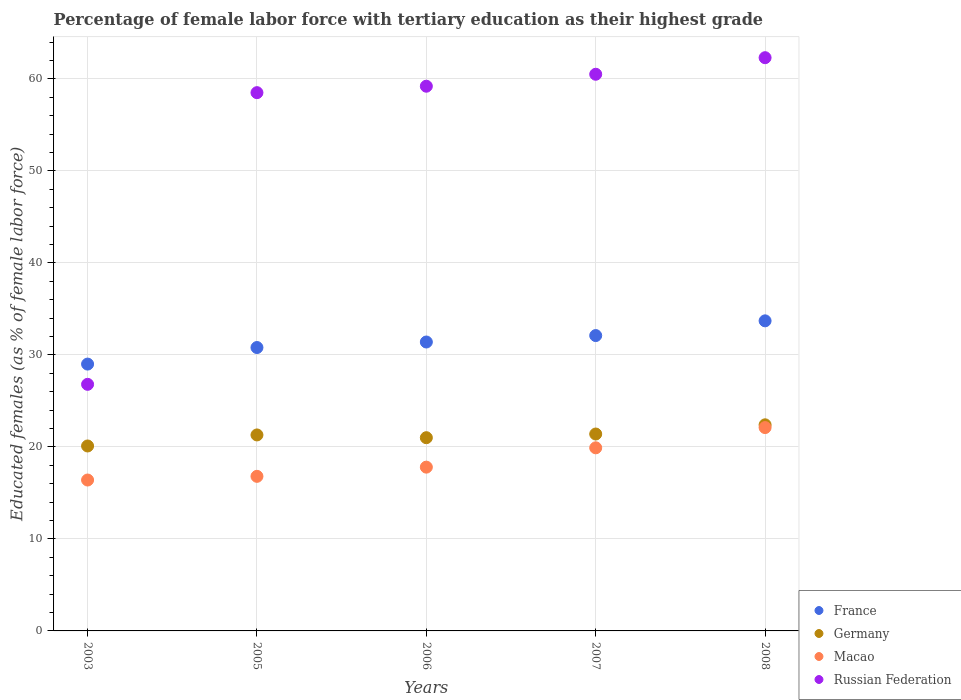How many different coloured dotlines are there?
Offer a very short reply. 4. What is the percentage of female labor force with tertiary education in France in 2007?
Your answer should be compact. 32.1. Across all years, what is the maximum percentage of female labor force with tertiary education in Russian Federation?
Keep it short and to the point. 62.3. Across all years, what is the minimum percentage of female labor force with tertiary education in Germany?
Ensure brevity in your answer.  20.1. What is the total percentage of female labor force with tertiary education in Macao in the graph?
Keep it short and to the point. 93. What is the difference between the percentage of female labor force with tertiary education in Macao in 2003 and that in 2005?
Your response must be concise. -0.4. What is the difference between the percentage of female labor force with tertiary education in France in 2006 and the percentage of female labor force with tertiary education in Russian Federation in 2005?
Give a very brief answer. -27.1. What is the average percentage of female labor force with tertiary education in Russian Federation per year?
Give a very brief answer. 53.46. In the year 2008, what is the difference between the percentage of female labor force with tertiary education in Macao and percentage of female labor force with tertiary education in Germany?
Offer a very short reply. -0.3. What is the ratio of the percentage of female labor force with tertiary education in Germany in 2005 to that in 2008?
Make the answer very short. 0.95. Is the percentage of female labor force with tertiary education in France in 2007 less than that in 2008?
Provide a short and direct response. Yes. Is the difference between the percentage of female labor force with tertiary education in Macao in 2003 and 2005 greater than the difference between the percentage of female labor force with tertiary education in Germany in 2003 and 2005?
Offer a very short reply. Yes. What is the difference between the highest and the second highest percentage of female labor force with tertiary education in Macao?
Give a very brief answer. 2.2. What is the difference between the highest and the lowest percentage of female labor force with tertiary education in France?
Offer a very short reply. 4.7. Is it the case that in every year, the sum of the percentage of female labor force with tertiary education in Macao and percentage of female labor force with tertiary education in France  is greater than the percentage of female labor force with tertiary education in Germany?
Offer a very short reply. Yes. Is the percentage of female labor force with tertiary education in Germany strictly less than the percentage of female labor force with tertiary education in France over the years?
Ensure brevity in your answer.  Yes. Where does the legend appear in the graph?
Keep it short and to the point. Bottom right. What is the title of the graph?
Provide a succinct answer. Percentage of female labor force with tertiary education as their highest grade. Does "Iceland" appear as one of the legend labels in the graph?
Provide a short and direct response. No. What is the label or title of the X-axis?
Give a very brief answer. Years. What is the label or title of the Y-axis?
Provide a succinct answer. Educated females (as % of female labor force). What is the Educated females (as % of female labor force) in France in 2003?
Your answer should be compact. 29. What is the Educated females (as % of female labor force) of Germany in 2003?
Offer a very short reply. 20.1. What is the Educated females (as % of female labor force) of Macao in 2003?
Provide a succinct answer. 16.4. What is the Educated females (as % of female labor force) of Russian Federation in 2003?
Ensure brevity in your answer.  26.8. What is the Educated females (as % of female labor force) of France in 2005?
Provide a short and direct response. 30.8. What is the Educated females (as % of female labor force) in Germany in 2005?
Ensure brevity in your answer.  21.3. What is the Educated females (as % of female labor force) of Macao in 2005?
Offer a very short reply. 16.8. What is the Educated females (as % of female labor force) in Russian Federation in 2005?
Give a very brief answer. 58.5. What is the Educated females (as % of female labor force) of France in 2006?
Give a very brief answer. 31.4. What is the Educated females (as % of female labor force) in Germany in 2006?
Give a very brief answer. 21. What is the Educated females (as % of female labor force) in Macao in 2006?
Ensure brevity in your answer.  17.8. What is the Educated females (as % of female labor force) of Russian Federation in 2006?
Your answer should be compact. 59.2. What is the Educated females (as % of female labor force) of France in 2007?
Make the answer very short. 32.1. What is the Educated females (as % of female labor force) in Germany in 2007?
Provide a short and direct response. 21.4. What is the Educated females (as % of female labor force) in Macao in 2007?
Your answer should be very brief. 19.9. What is the Educated females (as % of female labor force) in Russian Federation in 2007?
Give a very brief answer. 60.5. What is the Educated females (as % of female labor force) of France in 2008?
Give a very brief answer. 33.7. What is the Educated females (as % of female labor force) in Germany in 2008?
Ensure brevity in your answer.  22.4. What is the Educated females (as % of female labor force) in Macao in 2008?
Make the answer very short. 22.1. What is the Educated females (as % of female labor force) in Russian Federation in 2008?
Offer a terse response. 62.3. Across all years, what is the maximum Educated females (as % of female labor force) of France?
Your response must be concise. 33.7. Across all years, what is the maximum Educated females (as % of female labor force) of Germany?
Provide a short and direct response. 22.4. Across all years, what is the maximum Educated females (as % of female labor force) of Macao?
Provide a short and direct response. 22.1. Across all years, what is the maximum Educated females (as % of female labor force) of Russian Federation?
Provide a short and direct response. 62.3. Across all years, what is the minimum Educated females (as % of female labor force) of France?
Your answer should be very brief. 29. Across all years, what is the minimum Educated females (as % of female labor force) in Germany?
Your answer should be very brief. 20.1. Across all years, what is the minimum Educated females (as % of female labor force) in Macao?
Ensure brevity in your answer.  16.4. Across all years, what is the minimum Educated females (as % of female labor force) in Russian Federation?
Keep it short and to the point. 26.8. What is the total Educated females (as % of female labor force) of France in the graph?
Your answer should be very brief. 157. What is the total Educated females (as % of female labor force) in Germany in the graph?
Offer a terse response. 106.2. What is the total Educated females (as % of female labor force) of Macao in the graph?
Your answer should be compact. 93. What is the total Educated females (as % of female labor force) of Russian Federation in the graph?
Keep it short and to the point. 267.3. What is the difference between the Educated females (as % of female labor force) in Germany in 2003 and that in 2005?
Your answer should be very brief. -1.2. What is the difference between the Educated females (as % of female labor force) of Russian Federation in 2003 and that in 2005?
Give a very brief answer. -31.7. What is the difference between the Educated females (as % of female labor force) in France in 2003 and that in 2006?
Your answer should be very brief. -2.4. What is the difference between the Educated females (as % of female labor force) of Macao in 2003 and that in 2006?
Provide a short and direct response. -1.4. What is the difference between the Educated females (as % of female labor force) in Russian Federation in 2003 and that in 2006?
Your response must be concise. -32.4. What is the difference between the Educated females (as % of female labor force) of France in 2003 and that in 2007?
Ensure brevity in your answer.  -3.1. What is the difference between the Educated females (as % of female labor force) of Germany in 2003 and that in 2007?
Ensure brevity in your answer.  -1.3. What is the difference between the Educated females (as % of female labor force) in Russian Federation in 2003 and that in 2007?
Offer a terse response. -33.7. What is the difference between the Educated females (as % of female labor force) of Germany in 2003 and that in 2008?
Offer a very short reply. -2.3. What is the difference between the Educated females (as % of female labor force) of Macao in 2003 and that in 2008?
Provide a succinct answer. -5.7. What is the difference between the Educated females (as % of female labor force) in Russian Federation in 2003 and that in 2008?
Your response must be concise. -35.5. What is the difference between the Educated females (as % of female labor force) in Germany in 2005 and that in 2006?
Provide a succinct answer. 0.3. What is the difference between the Educated females (as % of female labor force) of Macao in 2005 and that in 2006?
Make the answer very short. -1. What is the difference between the Educated females (as % of female labor force) of France in 2005 and that in 2007?
Give a very brief answer. -1.3. What is the difference between the Educated females (as % of female labor force) of Macao in 2005 and that in 2007?
Offer a very short reply. -3.1. What is the difference between the Educated females (as % of female labor force) in Germany in 2005 and that in 2008?
Your response must be concise. -1.1. What is the difference between the Educated females (as % of female labor force) in Russian Federation in 2005 and that in 2008?
Provide a short and direct response. -3.8. What is the difference between the Educated females (as % of female labor force) of Germany in 2006 and that in 2007?
Offer a terse response. -0.4. What is the difference between the Educated females (as % of female labor force) in France in 2006 and that in 2008?
Ensure brevity in your answer.  -2.3. What is the difference between the Educated females (as % of female labor force) of Germany in 2006 and that in 2008?
Provide a succinct answer. -1.4. What is the difference between the Educated females (as % of female labor force) in Macao in 2006 and that in 2008?
Offer a terse response. -4.3. What is the difference between the Educated females (as % of female labor force) of Russian Federation in 2006 and that in 2008?
Your answer should be compact. -3.1. What is the difference between the Educated females (as % of female labor force) of France in 2003 and the Educated females (as % of female labor force) of Germany in 2005?
Your answer should be compact. 7.7. What is the difference between the Educated females (as % of female labor force) of France in 2003 and the Educated females (as % of female labor force) of Macao in 2005?
Offer a terse response. 12.2. What is the difference between the Educated females (as % of female labor force) in France in 2003 and the Educated females (as % of female labor force) in Russian Federation in 2005?
Offer a very short reply. -29.5. What is the difference between the Educated females (as % of female labor force) in Germany in 2003 and the Educated females (as % of female labor force) in Macao in 2005?
Give a very brief answer. 3.3. What is the difference between the Educated females (as % of female labor force) in Germany in 2003 and the Educated females (as % of female labor force) in Russian Federation in 2005?
Make the answer very short. -38.4. What is the difference between the Educated females (as % of female labor force) of Macao in 2003 and the Educated females (as % of female labor force) of Russian Federation in 2005?
Make the answer very short. -42.1. What is the difference between the Educated females (as % of female labor force) in France in 2003 and the Educated females (as % of female labor force) in Germany in 2006?
Ensure brevity in your answer.  8. What is the difference between the Educated females (as % of female labor force) of France in 2003 and the Educated females (as % of female labor force) of Russian Federation in 2006?
Your answer should be very brief. -30.2. What is the difference between the Educated females (as % of female labor force) of Germany in 2003 and the Educated females (as % of female labor force) of Macao in 2006?
Keep it short and to the point. 2.3. What is the difference between the Educated females (as % of female labor force) of Germany in 2003 and the Educated females (as % of female labor force) of Russian Federation in 2006?
Make the answer very short. -39.1. What is the difference between the Educated females (as % of female labor force) in Macao in 2003 and the Educated females (as % of female labor force) in Russian Federation in 2006?
Offer a very short reply. -42.8. What is the difference between the Educated females (as % of female labor force) of France in 2003 and the Educated females (as % of female labor force) of Germany in 2007?
Your response must be concise. 7.6. What is the difference between the Educated females (as % of female labor force) in France in 2003 and the Educated females (as % of female labor force) in Macao in 2007?
Make the answer very short. 9.1. What is the difference between the Educated females (as % of female labor force) of France in 2003 and the Educated females (as % of female labor force) of Russian Federation in 2007?
Your answer should be very brief. -31.5. What is the difference between the Educated females (as % of female labor force) of Germany in 2003 and the Educated females (as % of female labor force) of Macao in 2007?
Offer a very short reply. 0.2. What is the difference between the Educated females (as % of female labor force) of Germany in 2003 and the Educated females (as % of female labor force) of Russian Federation in 2007?
Offer a very short reply. -40.4. What is the difference between the Educated females (as % of female labor force) of Macao in 2003 and the Educated females (as % of female labor force) of Russian Federation in 2007?
Provide a succinct answer. -44.1. What is the difference between the Educated females (as % of female labor force) in France in 2003 and the Educated females (as % of female labor force) in Germany in 2008?
Give a very brief answer. 6.6. What is the difference between the Educated females (as % of female labor force) in France in 2003 and the Educated females (as % of female labor force) in Macao in 2008?
Keep it short and to the point. 6.9. What is the difference between the Educated females (as % of female labor force) of France in 2003 and the Educated females (as % of female labor force) of Russian Federation in 2008?
Offer a terse response. -33.3. What is the difference between the Educated females (as % of female labor force) in Germany in 2003 and the Educated females (as % of female labor force) in Russian Federation in 2008?
Your response must be concise. -42.2. What is the difference between the Educated females (as % of female labor force) of Macao in 2003 and the Educated females (as % of female labor force) of Russian Federation in 2008?
Keep it short and to the point. -45.9. What is the difference between the Educated females (as % of female labor force) in France in 2005 and the Educated females (as % of female labor force) in Germany in 2006?
Make the answer very short. 9.8. What is the difference between the Educated females (as % of female labor force) of France in 2005 and the Educated females (as % of female labor force) of Russian Federation in 2006?
Give a very brief answer. -28.4. What is the difference between the Educated females (as % of female labor force) of Germany in 2005 and the Educated females (as % of female labor force) of Russian Federation in 2006?
Give a very brief answer. -37.9. What is the difference between the Educated females (as % of female labor force) in Macao in 2005 and the Educated females (as % of female labor force) in Russian Federation in 2006?
Ensure brevity in your answer.  -42.4. What is the difference between the Educated females (as % of female labor force) in France in 2005 and the Educated females (as % of female labor force) in Germany in 2007?
Keep it short and to the point. 9.4. What is the difference between the Educated females (as % of female labor force) of France in 2005 and the Educated females (as % of female labor force) of Russian Federation in 2007?
Provide a short and direct response. -29.7. What is the difference between the Educated females (as % of female labor force) in Germany in 2005 and the Educated females (as % of female labor force) in Russian Federation in 2007?
Ensure brevity in your answer.  -39.2. What is the difference between the Educated females (as % of female labor force) in Macao in 2005 and the Educated females (as % of female labor force) in Russian Federation in 2007?
Provide a short and direct response. -43.7. What is the difference between the Educated females (as % of female labor force) in France in 2005 and the Educated females (as % of female labor force) in Macao in 2008?
Provide a short and direct response. 8.7. What is the difference between the Educated females (as % of female labor force) in France in 2005 and the Educated females (as % of female labor force) in Russian Federation in 2008?
Your response must be concise. -31.5. What is the difference between the Educated females (as % of female labor force) of Germany in 2005 and the Educated females (as % of female labor force) of Macao in 2008?
Provide a succinct answer. -0.8. What is the difference between the Educated females (as % of female labor force) of Germany in 2005 and the Educated females (as % of female labor force) of Russian Federation in 2008?
Offer a very short reply. -41. What is the difference between the Educated females (as % of female labor force) in Macao in 2005 and the Educated females (as % of female labor force) in Russian Federation in 2008?
Offer a very short reply. -45.5. What is the difference between the Educated females (as % of female labor force) of France in 2006 and the Educated females (as % of female labor force) of Russian Federation in 2007?
Your answer should be compact. -29.1. What is the difference between the Educated females (as % of female labor force) in Germany in 2006 and the Educated females (as % of female labor force) in Macao in 2007?
Provide a succinct answer. 1.1. What is the difference between the Educated females (as % of female labor force) of Germany in 2006 and the Educated females (as % of female labor force) of Russian Federation in 2007?
Offer a very short reply. -39.5. What is the difference between the Educated females (as % of female labor force) in Macao in 2006 and the Educated females (as % of female labor force) in Russian Federation in 2007?
Ensure brevity in your answer.  -42.7. What is the difference between the Educated females (as % of female labor force) of France in 2006 and the Educated females (as % of female labor force) of Germany in 2008?
Your answer should be very brief. 9. What is the difference between the Educated females (as % of female labor force) of France in 2006 and the Educated females (as % of female labor force) of Russian Federation in 2008?
Provide a short and direct response. -30.9. What is the difference between the Educated females (as % of female labor force) in Germany in 2006 and the Educated females (as % of female labor force) in Russian Federation in 2008?
Keep it short and to the point. -41.3. What is the difference between the Educated females (as % of female labor force) of Macao in 2006 and the Educated females (as % of female labor force) of Russian Federation in 2008?
Provide a succinct answer. -44.5. What is the difference between the Educated females (as % of female labor force) of France in 2007 and the Educated females (as % of female labor force) of Germany in 2008?
Make the answer very short. 9.7. What is the difference between the Educated females (as % of female labor force) of France in 2007 and the Educated females (as % of female labor force) of Macao in 2008?
Your answer should be compact. 10. What is the difference between the Educated females (as % of female labor force) in France in 2007 and the Educated females (as % of female labor force) in Russian Federation in 2008?
Provide a short and direct response. -30.2. What is the difference between the Educated females (as % of female labor force) of Germany in 2007 and the Educated females (as % of female labor force) of Macao in 2008?
Make the answer very short. -0.7. What is the difference between the Educated females (as % of female labor force) of Germany in 2007 and the Educated females (as % of female labor force) of Russian Federation in 2008?
Give a very brief answer. -40.9. What is the difference between the Educated females (as % of female labor force) in Macao in 2007 and the Educated females (as % of female labor force) in Russian Federation in 2008?
Your response must be concise. -42.4. What is the average Educated females (as % of female labor force) of France per year?
Keep it short and to the point. 31.4. What is the average Educated females (as % of female labor force) of Germany per year?
Make the answer very short. 21.24. What is the average Educated females (as % of female labor force) in Russian Federation per year?
Your answer should be compact. 53.46. In the year 2003, what is the difference between the Educated females (as % of female labor force) in France and Educated females (as % of female labor force) in Germany?
Offer a very short reply. 8.9. In the year 2003, what is the difference between the Educated females (as % of female labor force) in France and Educated females (as % of female labor force) in Macao?
Offer a terse response. 12.6. In the year 2003, what is the difference between the Educated females (as % of female labor force) in Germany and Educated females (as % of female labor force) in Macao?
Keep it short and to the point. 3.7. In the year 2003, what is the difference between the Educated females (as % of female labor force) in Macao and Educated females (as % of female labor force) in Russian Federation?
Keep it short and to the point. -10.4. In the year 2005, what is the difference between the Educated females (as % of female labor force) in France and Educated females (as % of female labor force) in Germany?
Ensure brevity in your answer.  9.5. In the year 2005, what is the difference between the Educated females (as % of female labor force) in France and Educated females (as % of female labor force) in Macao?
Offer a very short reply. 14. In the year 2005, what is the difference between the Educated females (as % of female labor force) of France and Educated females (as % of female labor force) of Russian Federation?
Your answer should be compact. -27.7. In the year 2005, what is the difference between the Educated females (as % of female labor force) of Germany and Educated females (as % of female labor force) of Russian Federation?
Your answer should be very brief. -37.2. In the year 2005, what is the difference between the Educated females (as % of female labor force) in Macao and Educated females (as % of female labor force) in Russian Federation?
Give a very brief answer. -41.7. In the year 2006, what is the difference between the Educated females (as % of female labor force) of France and Educated females (as % of female labor force) of Germany?
Offer a very short reply. 10.4. In the year 2006, what is the difference between the Educated females (as % of female labor force) of France and Educated females (as % of female labor force) of Russian Federation?
Ensure brevity in your answer.  -27.8. In the year 2006, what is the difference between the Educated females (as % of female labor force) in Germany and Educated females (as % of female labor force) in Macao?
Offer a terse response. 3.2. In the year 2006, what is the difference between the Educated females (as % of female labor force) of Germany and Educated females (as % of female labor force) of Russian Federation?
Offer a very short reply. -38.2. In the year 2006, what is the difference between the Educated females (as % of female labor force) in Macao and Educated females (as % of female labor force) in Russian Federation?
Provide a short and direct response. -41.4. In the year 2007, what is the difference between the Educated females (as % of female labor force) of France and Educated females (as % of female labor force) of Germany?
Offer a terse response. 10.7. In the year 2007, what is the difference between the Educated females (as % of female labor force) of France and Educated females (as % of female labor force) of Macao?
Offer a very short reply. 12.2. In the year 2007, what is the difference between the Educated females (as % of female labor force) of France and Educated females (as % of female labor force) of Russian Federation?
Offer a terse response. -28.4. In the year 2007, what is the difference between the Educated females (as % of female labor force) in Germany and Educated females (as % of female labor force) in Macao?
Provide a short and direct response. 1.5. In the year 2007, what is the difference between the Educated females (as % of female labor force) of Germany and Educated females (as % of female labor force) of Russian Federation?
Your answer should be compact. -39.1. In the year 2007, what is the difference between the Educated females (as % of female labor force) in Macao and Educated females (as % of female labor force) in Russian Federation?
Provide a succinct answer. -40.6. In the year 2008, what is the difference between the Educated females (as % of female labor force) in France and Educated females (as % of female labor force) in Germany?
Offer a very short reply. 11.3. In the year 2008, what is the difference between the Educated females (as % of female labor force) of France and Educated females (as % of female labor force) of Macao?
Offer a terse response. 11.6. In the year 2008, what is the difference between the Educated females (as % of female labor force) of France and Educated females (as % of female labor force) of Russian Federation?
Provide a short and direct response. -28.6. In the year 2008, what is the difference between the Educated females (as % of female labor force) in Germany and Educated females (as % of female labor force) in Macao?
Ensure brevity in your answer.  0.3. In the year 2008, what is the difference between the Educated females (as % of female labor force) in Germany and Educated females (as % of female labor force) in Russian Federation?
Offer a terse response. -39.9. In the year 2008, what is the difference between the Educated females (as % of female labor force) in Macao and Educated females (as % of female labor force) in Russian Federation?
Make the answer very short. -40.2. What is the ratio of the Educated females (as % of female labor force) in France in 2003 to that in 2005?
Offer a terse response. 0.94. What is the ratio of the Educated females (as % of female labor force) of Germany in 2003 to that in 2005?
Your response must be concise. 0.94. What is the ratio of the Educated females (as % of female labor force) of Macao in 2003 to that in 2005?
Offer a terse response. 0.98. What is the ratio of the Educated females (as % of female labor force) of Russian Federation in 2003 to that in 2005?
Your answer should be compact. 0.46. What is the ratio of the Educated females (as % of female labor force) in France in 2003 to that in 2006?
Your response must be concise. 0.92. What is the ratio of the Educated females (as % of female labor force) of Germany in 2003 to that in 2006?
Offer a very short reply. 0.96. What is the ratio of the Educated females (as % of female labor force) of Macao in 2003 to that in 2006?
Your response must be concise. 0.92. What is the ratio of the Educated females (as % of female labor force) of Russian Federation in 2003 to that in 2006?
Provide a short and direct response. 0.45. What is the ratio of the Educated females (as % of female labor force) in France in 2003 to that in 2007?
Your answer should be very brief. 0.9. What is the ratio of the Educated females (as % of female labor force) in Germany in 2003 to that in 2007?
Offer a very short reply. 0.94. What is the ratio of the Educated females (as % of female labor force) of Macao in 2003 to that in 2007?
Offer a terse response. 0.82. What is the ratio of the Educated females (as % of female labor force) of Russian Federation in 2003 to that in 2007?
Make the answer very short. 0.44. What is the ratio of the Educated females (as % of female labor force) in France in 2003 to that in 2008?
Ensure brevity in your answer.  0.86. What is the ratio of the Educated females (as % of female labor force) in Germany in 2003 to that in 2008?
Your answer should be very brief. 0.9. What is the ratio of the Educated females (as % of female labor force) of Macao in 2003 to that in 2008?
Your response must be concise. 0.74. What is the ratio of the Educated females (as % of female labor force) in Russian Federation in 2003 to that in 2008?
Keep it short and to the point. 0.43. What is the ratio of the Educated females (as % of female labor force) in France in 2005 to that in 2006?
Give a very brief answer. 0.98. What is the ratio of the Educated females (as % of female labor force) of Germany in 2005 to that in 2006?
Offer a very short reply. 1.01. What is the ratio of the Educated females (as % of female labor force) of Macao in 2005 to that in 2006?
Your answer should be very brief. 0.94. What is the ratio of the Educated females (as % of female labor force) in Russian Federation in 2005 to that in 2006?
Give a very brief answer. 0.99. What is the ratio of the Educated females (as % of female labor force) in France in 2005 to that in 2007?
Provide a succinct answer. 0.96. What is the ratio of the Educated females (as % of female labor force) of Germany in 2005 to that in 2007?
Your answer should be very brief. 1. What is the ratio of the Educated females (as % of female labor force) of Macao in 2005 to that in 2007?
Offer a terse response. 0.84. What is the ratio of the Educated females (as % of female labor force) in Russian Federation in 2005 to that in 2007?
Your response must be concise. 0.97. What is the ratio of the Educated females (as % of female labor force) in France in 2005 to that in 2008?
Offer a very short reply. 0.91. What is the ratio of the Educated females (as % of female labor force) in Germany in 2005 to that in 2008?
Your response must be concise. 0.95. What is the ratio of the Educated females (as % of female labor force) in Macao in 2005 to that in 2008?
Your answer should be compact. 0.76. What is the ratio of the Educated females (as % of female labor force) in Russian Federation in 2005 to that in 2008?
Keep it short and to the point. 0.94. What is the ratio of the Educated females (as % of female labor force) of France in 2006 to that in 2007?
Make the answer very short. 0.98. What is the ratio of the Educated females (as % of female labor force) in Germany in 2006 to that in 2007?
Make the answer very short. 0.98. What is the ratio of the Educated females (as % of female labor force) in Macao in 2006 to that in 2007?
Ensure brevity in your answer.  0.89. What is the ratio of the Educated females (as % of female labor force) of Russian Federation in 2006 to that in 2007?
Give a very brief answer. 0.98. What is the ratio of the Educated females (as % of female labor force) of France in 2006 to that in 2008?
Your answer should be very brief. 0.93. What is the ratio of the Educated females (as % of female labor force) of Macao in 2006 to that in 2008?
Your answer should be compact. 0.81. What is the ratio of the Educated females (as % of female labor force) in Russian Federation in 2006 to that in 2008?
Give a very brief answer. 0.95. What is the ratio of the Educated females (as % of female labor force) of France in 2007 to that in 2008?
Your answer should be compact. 0.95. What is the ratio of the Educated females (as % of female labor force) of Germany in 2007 to that in 2008?
Give a very brief answer. 0.96. What is the ratio of the Educated females (as % of female labor force) in Macao in 2007 to that in 2008?
Give a very brief answer. 0.9. What is the ratio of the Educated females (as % of female labor force) of Russian Federation in 2007 to that in 2008?
Offer a terse response. 0.97. What is the difference between the highest and the second highest Educated females (as % of female labor force) in France?
Make the answer very short. 1.6. What is the difference between the highest and the second highest Educated females (as % of female labor force) of Germany?
Offer a terse response. 1. What is the difference between the highest and the second highest Educated females (as % of female labor force) of Russian Federation?
Make the answer very short. 1.8. What is the difference between the highest and the lowest Educated females (as % of female labor force) of France?
Make the answer very short. 4.7. What is the difference between the highest and the lowest Educated females (as % of female labor force) in Germany?
Ensure brevity in your answer.  2.3. What is the difference between the highest and the lowest Educated females (as % of female labor force) of Russian Federation?
Your answer should be very brief. 35.5. 